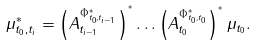<formula> <loc_0><loc_0><loc_500><loc_500>\mu _ { t _ { 0 } , t _ { i } } ^ { * } = \left ( A _ { t _ { i - 1 } } ^ { \Phi _ { t _ { 0 } , t _ { i - 1 } } ^ { * } } \right ) ^ { ^ { * } } \dots \left ( A _ { t _ { 0 } } ^ { \Phi _ { t _ { 0 } , t _ { 0 } } ^ { * } } \right ) ^ { ^ { * } } \mu _ { t _ { 0 } } .</formula> 